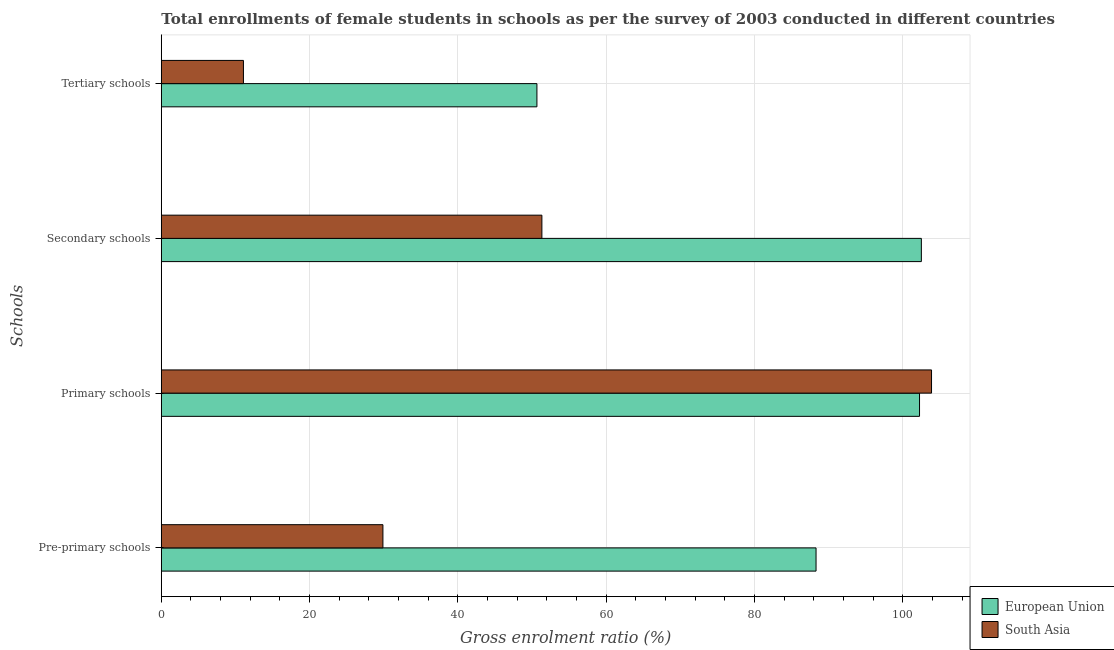How many different coloured bars are there?
Ensure brevity in your answer.  2. How many groups of bars are there?
Make the answer very short. 4. How many bars are there on the 3rd tick from the bottom?
Provide a short and direct response. 2. What is the label of the 4th group of bars from the top?
Provide a succinct answer. Pre-primary schools. What is the gross enrolment ratio(female) in tertiary schools in European Union?
Your answer should be very brief. 50.65. Across all countries, what is the maximum gross enrolment ratio(female) in tertiary schools?
Your answer should be very brief. 50.65. Across all countries, what is the minimum gross enrolment ratio(female) in pre-primary schools?
Keep it short and to the point. 29.88. In which country was the gross enrolment ratio(female) in secondary schools minimum?
Provide a short and direct response. South Asia. What is the total gross enrolment ratio(female) in tertiary schools in the graph?
Give a very brief answer. 61.72. What is the difference between the gross enrolment ratio(female) in tertiary schools in South Asia and that in European Union?
Offer a terse response. -39.58. What is the difference between the gross enrolment ratio(female) in pre-primary schools in European Union and the gross enrolment ratio(female) in primary schools in South Asia?
Provide a short and direct response. -15.57. What is the average gross enrolment ratio(female) in secondary schools per country?
Make the answer very short. 76.9. What is the difference between the gross enrolment ratio(female) in tertiary schools and gross enrolment ratio(female) in secondary schools in European Union?
Provide a succinct answer. -51.84. In how many countries, is the gross enrolment ratio(female) in pre-primary schools greater than 76 %?
Make the answer very short. 1. What is the ratio of the gross enrolment ratio(female) in secondary schools in South Asia to that in European Union?
Your answer should be compact. 0.5. Is the gross enrolment ratio(female) in pre-primary schools in South Asia less than that in European Union?
Make the answer very short. Yes. What is the difference between the highest and the second highest gross enrolment ratio(female) in pre-primary schools?
Your answer should be compact. 58.41. What is the difference between the highest and the lowest gross enrolment ratio(female) in primary schools?
Your answer should be very brief. 1.62. In how many countries, is the gross enrolment ratio(female) in tertiary schools greater than the average gross enrolment ratio(female) in tertiary schools taken over all countries?
Provide a short and direct response. 1. Is the sum of the gross enrolment ratio(female) in primary schools in European Union and South Asia greater than the maximum gross enrolment ratio(female) in pre-primary schools across all countries?
Make the answer very short. Yes. What does the 2nd bar from the top in Primary schools represents?
Offer a very short reply. European Union. How many bars are there?
Your answer should be compact. 8. Are all the bars in the graph horizontal?
Ensure brevity in your answer.  Yes. How many countries are there in the graph?
Make the answer very short. 2. What is the difference between two consecutive major ticks on the X-axis?
Provide a succinct answer. 20. Does the graph contain grids?
Provide a succinct answer. Yes. Where does the legend appear in the graph?
Keep it short and to the point. Bottom right. How many legend labels are there?
Give a very brief answer. 2. What is the title of the graph?
Your response must be concise. Total enrollments of female students in schools as per the survey of 2003 conducted in different countries. Does "Puerto Rico" appear as one of the legend labels in the graph?
Ensure brevity in your answer.  No. What is the label or title of the Y-axis?
Offer a terse response. Schools. What is the Gross enrolment ratio (%) in European Union in Pre-primary schools?
Offer a terse response. 88.29. What is the Gross enrolment ratio (%) of South Asia in Pre-primary schools?
Offer a terse response. 29.88. What is the Gross enrolment ratio (%) in European Union in Primary schools?
Keep it short and to the point. 102.24. What is the Gross enrolment ratio (%) of South Asia in Primary schools?
Provide a short and direct response. 103.86. What is the Gross enrolment ratio (%) of European Union in Secondary schools?
Your response must be concise. 102.49. What is the Gross enrolment ratio (%) in South Asia in Secondary schools?
Provide a succinct answer. 51.32. What is the Gross enrolment ratio (%) in European Union in Tertiary schools?
Provide a succinct answer. 50.65. What is the Gross enrolment ratio (%) of South Asia in Tertiary schools?
Your answer should be compact. 11.07. Across all Schools, what is the maximum Gross enrolment ratio (%) of European Union?
Ensure brevity in your answer.  102.49. Across all Schools, what is the maximum Gross enrolment ratio (%) of South Asia?
Provide a short and direct response. 103.86. Across all Schools, what is the minimum Gross enrolment ratio (%) in European Union?
Your answer should be compact. 50.65. Across all Schools, what is the minimum Gross enrolment ratio (%) in South Asia?
Ensure brevity in your answer.  11.07. What is the total Gross enrolment ratio (%) of European Union in the graph?
Your response must be concise. 343.67. What is the total Gross enrolment ratio (%) of South Asia in the graph?
Your response must be concise. 196.14. What is the difference between the Gross enrolment ratio (%) of European Union in Pre-primary schools and that in Primary schools?
Your answer should be very brief. -13.96. What is the difference between the Gross enrolment ratio (%) in South Asia in Pre-primary schools and that in Primary schools?
Ensure brevity in your answer.  -73.98. What is the difference between the Gross enrolment ratio (%) of European Union in Pre-primary schools and that in Secondary schools?
Provide a succinct answer. -14.2. What is the difference between the Gross enrolment ratio (%) in South Asia in Pre-primary schools and that in Secondary schools?
Offer a terse response. -21.44. What is the difference between the Gross enrolment ratio (%) in European Union in Pre-primary schools and that in Tertiary schools?
Offer a very short reply. 37.64. What is the difference between the Gross enrolment ratio (%) in South Asia in Pre-primary schools and that in Tertiary schools?
Provide a short and direct response. 18.81. What is the difference between the Gross enrolment ratio (%) in European Union in Primary schools and that in Secondary schools?
Your answer should be compact. -0.25. What is the difference between the Gross enrolment ratio (%) in South Asia in Primary schools and that in Secondary schools?
Your response must be concise. 52.54. What is the difference between the Gross enrolment ratio (%) of European Union in Primary schools and that in Tertiary schools?
Give a very brief answer. 51.59. What is the difference between the Gross enrolment ratio (%) in South Asia in Primary schools and that in Tertiary schools?
Provide a succinct answer. 92.79. What is the difference between the Gross enrolment ratio (%) in European Union in Secondary schools and that in Tertiary schools?
Your answer should be very brief. 51.84. What is the difference between the Gross enrolment ratio (%) in South Asia in Secondary schools and that in Tertiary schools?
Offer a terse response. 40.24. What is the difference between the Gross enrolment ratio (%) of European Union in Pre-primary schools and the Gross enrolment ratio (%) of South Asia in Primary schools?
Your answer should be very brief. -15.57. What is the difference between the Gross enrolment ratio (%) in European Union in Pre-primary schools and the Gross enrolment ratio (%) in South Asia in Secondary schools?
Keep it short and to the point. 36.97. What is the difference between the Gross enrolment ratio (%) of European Union in Pre-primary schools and the Gross enrolment ratio (%) of South Asia in Tertiary schools?
Your answer should be very brief. 77.21. What is the difference between the Gross enrolment ratio (%) in European Union in Primary schools and the Gross enrolment ratio (%) in South Asia in Secondary schools?
Ensure brevity in your answer.  50.92. What is the difference between the Gross enrolment ratio (%) of European Union in Primary schools and the Gross enrolment ratio (%) of South Asia in Tertiary schools?
Your answer should be very brief. 91.17. What is the difference between the Gross enrolment ratio (%) in European Union in Secondary schools and the Gross enrolment ratio (%) in South Asia in Tertiary schools?
Make the answer very short. 91.42. What is the average Gross enrolment ratio (%) in European Union per Schools?
Ensure brevity in your answer.  85.92. What is the average Gross enrolment ratio (%) in South Asia per Schools?
Your answer should be compact. 49.03. What is the difference between the Gross enrolment ratio (%) of European Union and Gross enrolment ratio (%) of South Asia in Pre-primary schools?
Make the answer very short. 58.41. What is the difference between the Gross enrolment ratio (%) of European Union and Gross enrolment ratio (%) of South Asia in Primary schools?
Offer a very short reply. -1.62. What is the difference between the Gross enrolment ratio (%) in European Union and Gross enrolment ratio (%) in South Asia in Secondary schools?
Your response must be concise. 51.17. What is the difference between the Gross enrolment ratio (%) of European Union and Gross enrolment ratio (%) of South Asia in Tertiary schools?
Provide a succinct answer. 39.58. What is the ratio of the Gross enrolment ratio (%) in European Union in Pre-primary schools to that in Primary schools?
Give a very brief answer. 0.86. What is the ratio of the Gross enrolment ratio (%) of South Asia in Pre-primary schools to that in Primary schools?
Make the answer very short. 0.29. What is the ratio of the Gross enrolment ratio (%) in European Union in Pre-primary schools to that in Secondary schools?
Keep it short and to the point. 0.86. What is the ratio of the Gross enrolment ratio (%) in South Asia in Pre-primary schools to that in Secondary schools?
Make the answer very short. 0.58. What is the ratio of the Gross enrolment ratio (%) of European Union in Pre-primary schools to that in Tertiary schools?
Your answer should be very brief. 1.74. What is the ratio of the Gross enrolment ratio (%) in South Asia in Pre-primary schools to that in Tertiary schools?
Give a very brief answer. 2.7. What is the ratio of the Gross enrolment ratio (%) of European Union in Primary schools to that in Secondary schools?
Make the answer very short. 1. What is the ratio of the Gross enrolment ratio (%) of South Asia in Primary schools to that in Secondary schools?
Make the answer very short. 2.02. What is the ratio of the Gross enrolment ratio (%) of European Union in Primary schools to that in Tertiary schools?
Your response must be concise. 2.02. What is the ratio of the Gross enrolment ratio (%) of South Asia in Primary schools to that in Tertiary schools?
Offer a very short reply. 9.38. What is the ratio of the Gross enrolment ratio (%) of European Union in Secondary schools to that in Tertiary schools?
Ensure brevity in your answer.  2.02. What is the ratio of the Gross enrolment ratio (%) in South Asia in Secondary schools to that in Tertiary schools?
Keep it short and to the point. 4.63. What is the difference between the highest and the second highest Gross enrolment ratio (%) in European Union?
Provide a short and direct response. 0.25. What is the difference between the highest and the second highest Gross enrolment ratio (%) in South Asia?
Your response must be concise. 52.54. What is the difference between the highest and the lowest Gross enrolment ratio (%) in European Union?
Keep it short and to the point. 51.84. What is the difference between the highest and the lowest Gross enrolment ratio (%) in South Asia?
Your response must be concise. 92.79. 